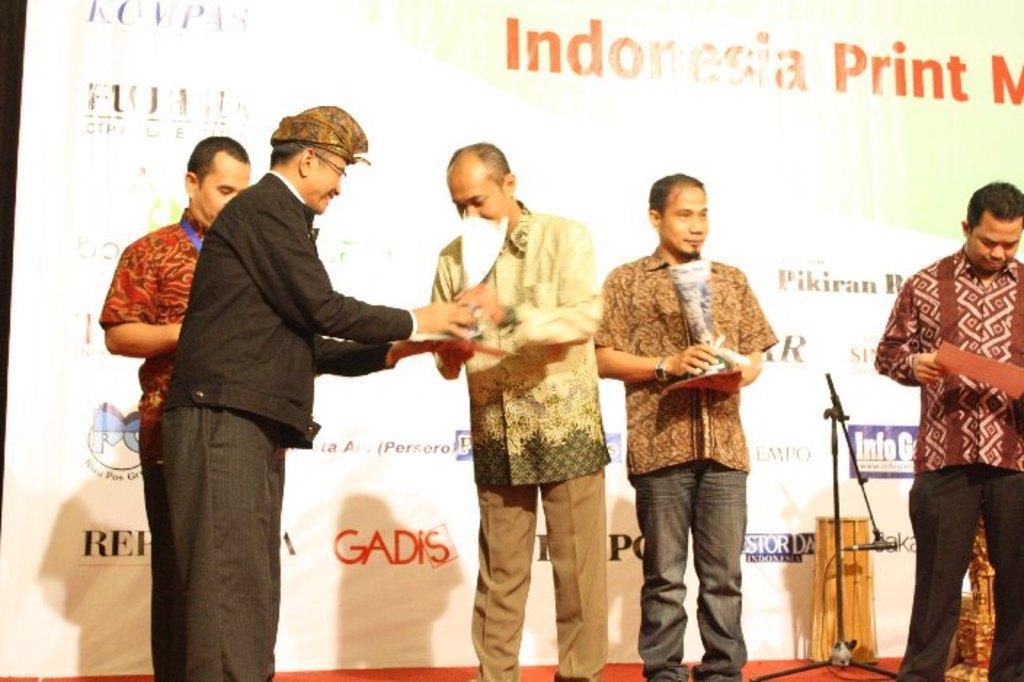Please provide a concise description of this image. In this image we can see some people standing on the stage and holding some objects and there is a mic stand. We can see a banner with some text in the background. 